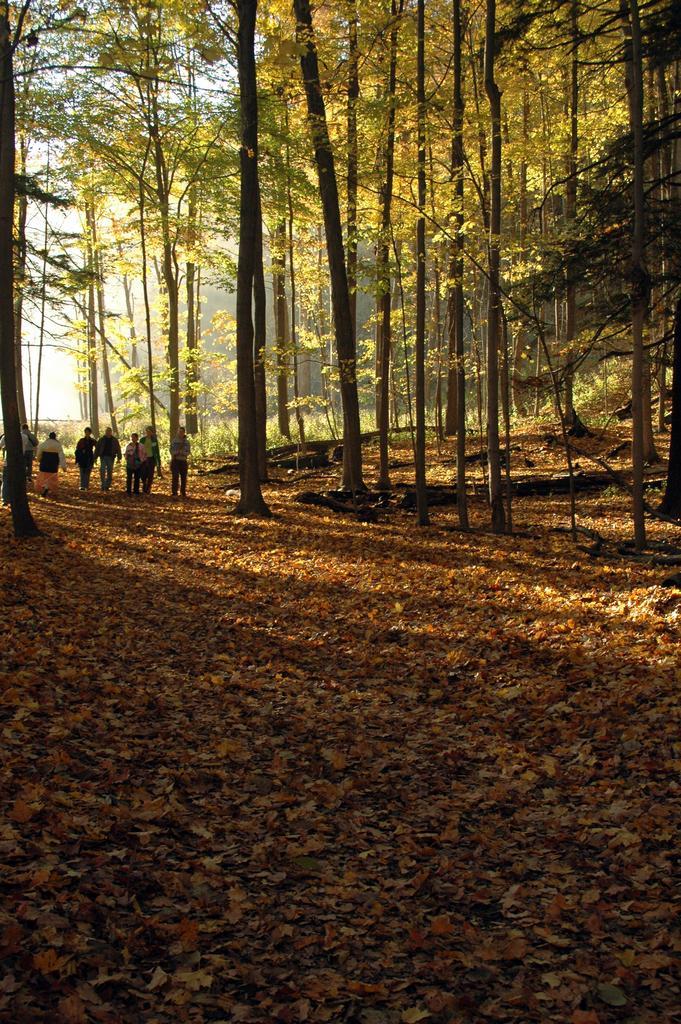Could you give a brief overview of what you see in this image? In the foreground we can see the leaves on the ground. In the background, we can see a few persons and trees. 